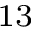Convert formula to latex. <formula><loc_0><loc_0><loc_500><loc_500>^ { 1 3 }</formula> 